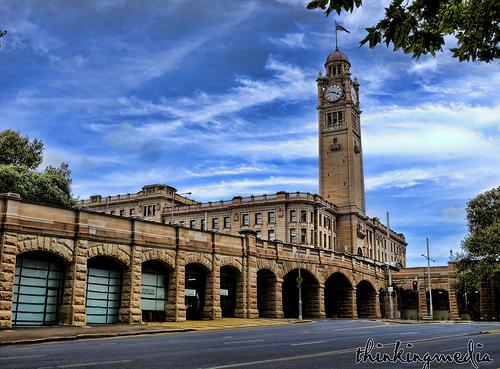Please list the objects found surrounding the building in this image. A tree behind the building, a tall tower, window, clock, flag, row of windows on the side, and a brown guard railing on the roof. What type of pole is near the road and what can be identified on or near the pole? A silver metal pole beside the road with a yellow metal sign and a nearby red traffic signal. Provide a brief description of the clock tower in the image. A tall brick clock tower with a clock face on a stone background, windows on the side, and a flag on top. Describe the general sentiment or feeling conveyed by this image. A peaceful and serene atmosphere created by the combination of the blue sky, green trees, and architectural elements. Mention any object that seems to be interacting with another object in the image. The flag is waving on top of the clock tower, indicating an interaction between the flag and the tower. Explain the appearance of the tall leafy green tree in this picture. The tree has green leaves covering its branches, creating a full and lush appearance. What does the sky look like in this image? A cloudy blue sky with lots of white clouds. Can you identify the color of the street in the image and any markings on it? The street is grey and has white lines painted on the road pavement. Which object appears to be the smallest in the image and what are its dimensions? The smallest object is a window on the building with dimensions Width:7 and Height:7. How many trees are in the image and what are their characteristics? Three trees: a tree behind the building, a tree near the building, and a tall leafy green tree. All are covered in green leaves. 